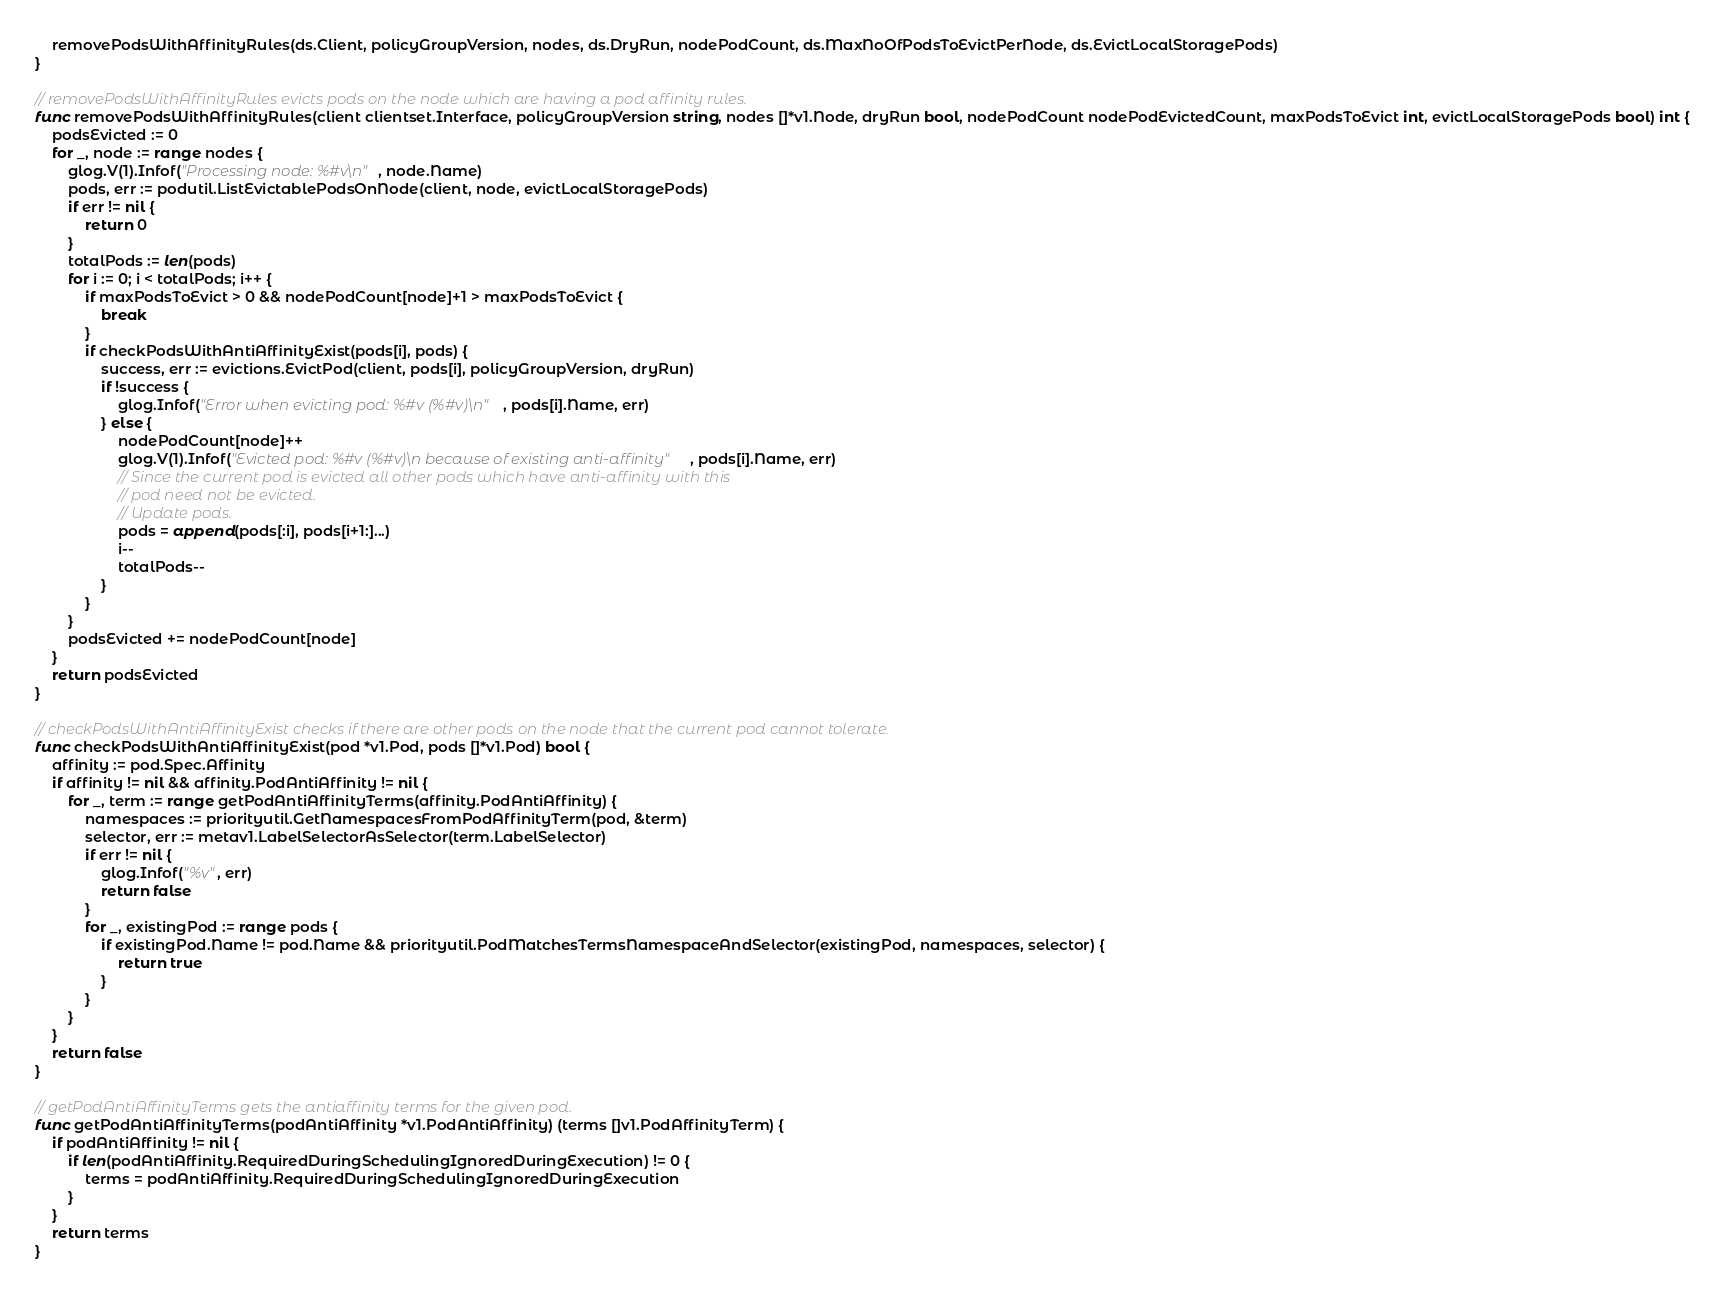Convert code to text. <code><loc_0><loc_0><loc_500><loc_500><_Go_>	removePodsWithAffinityRules(ds.Client, policyGroupVersion, nodes, ds.DryRun, nodePodCount, ds.MaxNoOfPodsToEvictPerNode, ds.EvictLocalStoragePods)
}

// removePodsWithAffinityRules evicts pods on the node which are having a pod affinity rules.
func removePodsWithAffinityRules(client clientset.Interface, policyGroupVersion string, nodes []*v1.Node, dryRun bool, nodePodCount nodePodEvictedCount, maxPodsToEvict int, evictLocalStoragePods bool) int {
	podsEvicted := 0
	for _, node := range nodes {
		glog.V(1).Infof("Processing node: %#v\n", node.Name)
		pods, err := podutil.ListEvictablePodsOnNode(client, node, evictLocalStoragePods)
		if err != nil {
			return 0
		}
		totalPods := len(pods)
		for i := 0; i < totalPods; i++ {
			if maxPodsToEvict > 0 && nodePodCount[node]+1 > maxPodsToEvict {
				break
			}
			if checkPodsWithAntiAffinityExist(pods[i], pods) {
				success, err := evictions.EvictPod(client, pods[i], policyGroupVersion, dryRun)
				if !success {
					glog.Infof("Error when evicting pod: %#v (%#v)\n", pods[i].Name, err)
				} else {
					nodePodCount[node]++
					glog.V(1).Infof("Evicted pod: %#v (%#v)\n because of existing anti-affinity", pods[i].Name, err)
					// Since the current pod is evicted all other pods which have anti-affinity with this
					// pod need not be evicted.
					// Update pods.
					pods = append(pods[:i], pods[i+1:]...)
					i--
					totalPods--
				}
			}
		}
		podsEvicted += nodePodCount[node]
	}
	return podsEvicted
}

// checkPodsWithAntiAffinityExist checks if there are other pods on the node that the current pod cannot tolerate.
func checkPodsWithAntiAffinityExist(pod *v1.Pod, pods []*v1.Pod) bool {
	affinity := pod.Spec.Affinity
	if affinity != nil && affinity.PodAntiAffinity != nil {
		for _, term := range getPodAntiAffinityTerms(affinity.PodAntiAffinity) {
			namespaces := priorityutil.GetNamespacesFromPodAffinityTerm(pod, &term)
			selector, err := metav1.LabelSelectorAsSelector(term.LabelSelector)
			if err != nil {
				glog.Infof("%v", err)
				return false
			}
			for _, existingPod := range pods {
				if existingPod.Name != pod.Name && priorityutil.PodMatchesTermsNamespaceAndSelector(existingPod, namespaces, selector) {
					return true
				}
			}
		}
	}
	return false
}

// getPodAntiAffinityTerms gets the antiaffinity terms for the given pod.
func getPodAntiAffinityTerms(podAntiAffinity *v1.PodAntiAffinity) (terms []v1.PodAffinityTerm) {
	if podAntiAffinity != nil {
		if len(podAntiAffinity.RequiredDuringSchedulingIgnoredDuringExecution) != 0 {
			terms = podAntiAffinity.RequiredDuringSchedulingIgnoredDuringExecution
		}
	}
	return terms
}
</code> 